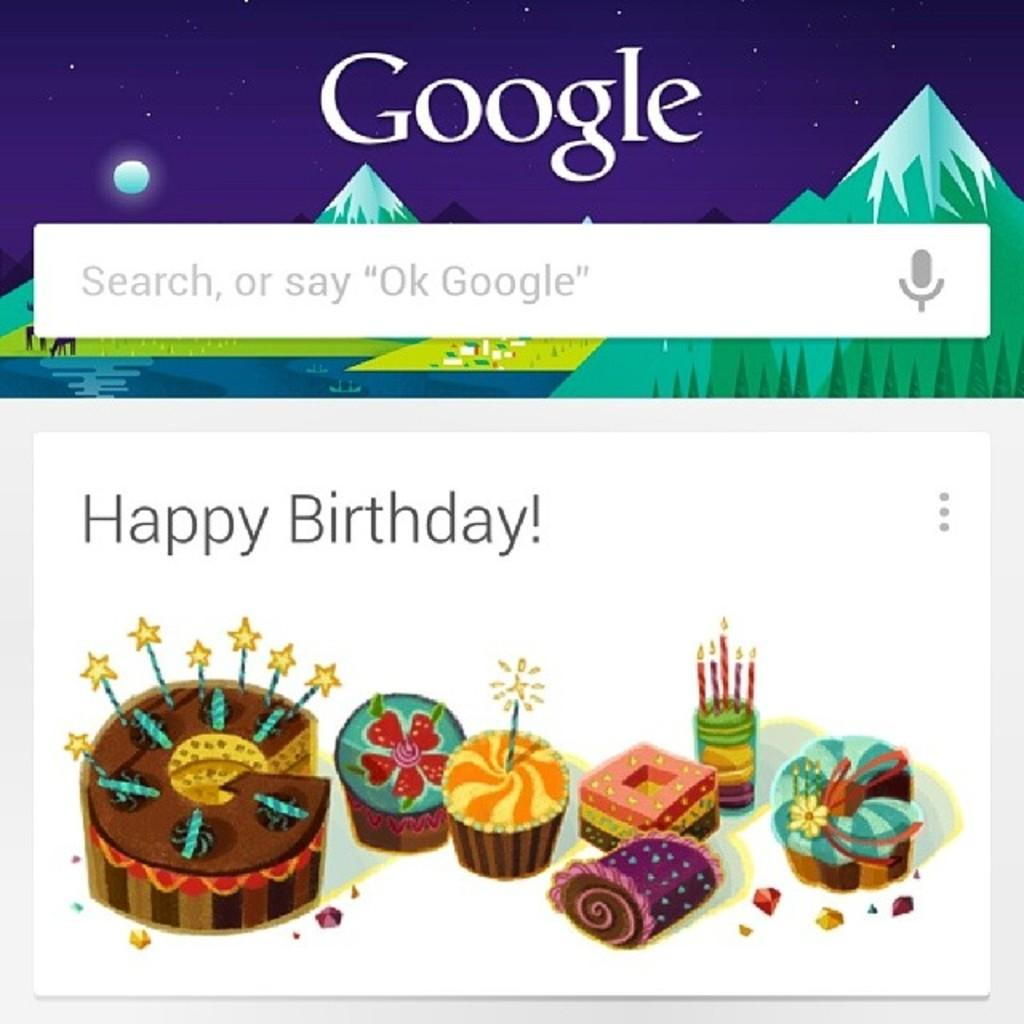What is the main subject of the poster in the image? The main subject of the poster in the image is an animated image of cakes and candles at the bottom. Where is the search box located on the poster? The search box is at the top of the poster. What color is the paint on the board in the image? There is no paint or board present in the image; it features a poster with an animated image of cakes and candles and a search box. 